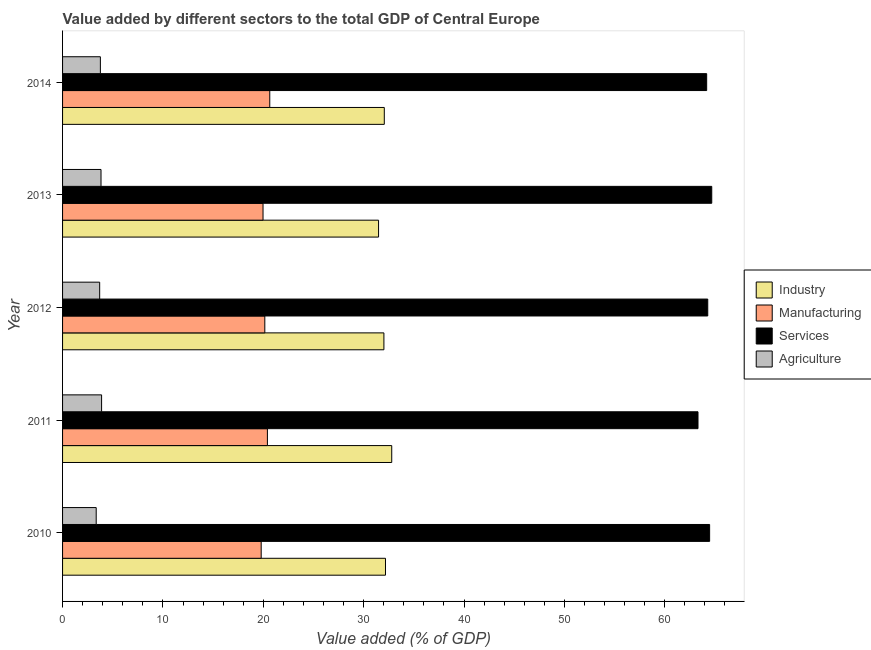How many groups of bars are there?
Your answer should be very brief. 5. What is the value added by manufacturing sector in 2011?
Offer a terse response. 20.41. Across all years, what is the maximum value added by agricultural sector?
Provide a short and direct response. 3.89. Across all years, what is the minimum value added by manufacturing sector?
Your answer should be very brief. 19.79. In which year was the value added by agricultural sector minimum?
Give a very brief answer. 2010. What is the total value added by manufacturing sector in the graph?
Provide a succinct answer. 100.97. What is the difference between the value added by industrial sector in 2012 and that in 2013?
Your answer should be compact. 0.53. What is the difference between the value added by manufacturing sector in 2014 and the value added by services sector in 2012?
Make the answer very short. -43.64. What is the average value added by services sector per year?
Your answer should be compact. 64.19. In the year 2014, what is the difference between the value added by services sector and value added by agricultural sector?
Ensure brevity in your answer.  60.41. In how many years, is the value added by services sector greater than 46 %?
Keep it short and to the point. 5. What is the ratio of the value added by manufacturing sector in 2010 to that in 2011?
Offer a terse response. 0.97. Is the value added by industrial sector in 2010 less than that in 2011?
Make the answer very short. Yes. What is the difference between the highest and the second highest value added by industrial sector?
Provide a short and direct response. 0.62. What is the difference between the highest and the lowest value added by industrial sector?
Keep it short and to the point. 1.31. What does the 2nd bar from the top in 2013 represents?
Your response must be concise. Services. What does the 4th bar from the bottom in 2012 represents?
Provide a succinct answer. Agriculture. How many bars are there?
Provide a succinct answer. 20. Are all the bars in the graph horizontal?
Your answer should be compact. Yes. How many years are there in the graph?
Provide a short and direct response. 5. What is the difference between two consecutive major ticks on the X-axis?
Ensure brevity in your answer.  10. Does the graph contain any zero values?
Ensure brevity in your answer.  No. Does the graph contain grids?
Your answer should be compact. No. What is the title of the graph?
Give a very brief answer. Value added by different sectors to the total GDP of Central Europe. Does "Corruption" appear as one of the legend labels in the graph?
Your response must be concise. No. What is the label or title of the X-axis?
Keep it short and to the point. Value added (% of GDP). What is the label or title of the Y-axis?
Your answer should be compact. Year. What is the Value added (% of GDP) in Industry in 2010?
Make the answer very short. 32.18. What is the Value added (% of GDP) of Manufacturing in 2010?
Provide a succinct answer. 19.79. What is the Value added (% of GDP) of Services in 2010?
Your answer should be compact. 64.47. What is the Value added (% of GDP) in Agriculture in 2010?
Offer a terse response. 3.35. What is the Value added (% of GDP) in Industry in 2011?
Offer a terse response. 32.8. What is the Value added (% of GDP) of Manufacturing in 2011?
Your answer should be very brief. 20.41. What is the Value added (% of GDP) of Services in 2011?
Your answer should be very brief. 63.31. What is the Value added (% of GDP) in Agriculture in 2011?
Your answer should be very brief. 3.89. What is the Value added (% of GDP) in Industry in 2012?
Your answer should be compact. 32.02. What is the Value added (% of GDP) in Manufacturing in 2012?
Ensure brevity in your answer.  20.15. What is the Value added (% of GDP) in Services in 2012?
Provide a succinct answer. 64.28. What is the Value added (% of GDP) in Agriculture in 2012?
Offer a terse response. 3.7. What is the Value added (% of GDP) of Industry in 2013?
Make the answer very short. 31.49. What is the Value added (% of GDP) of Manufacturing in 2013?
Keep it short and to the point. 19.97. What is the Value added (% of GDP) in Services in 2013?
Ensure brevity in your answer.  64.68. What is the Value added (% of GDP) of Agriculture in 2013?
Provide a short and direct response. 3.83. What is the Value added (% of GDP) in Industry in 2014?
Provide a succinct answer. 32.06. What is the Value added (% of GDP) of Manufacturing in 2014?
Provide a succinct answer. 20.65. What is the Value added (% of GDP) in Services in 2014?
Offer a very short reply. 64.18. What is the Value added (% of GDP) of Agriculture in 2014?
Offer a very short reply. 3.77. Across all years, what is the maximum Value added (% of GDP) of Industry?
Ensure brevity in your answer.  32.8. Across all years, what is the maximum Value added (% of GDP) of Manufacturing?
Offer a very short reply. 20.65. Across all years, what is the maximum Value added (% of GDP) in Services?
Make the answer very short. 64.68. Across all years, what is the maximum Value added (% of GDP) of Agriculture?
Your answer should be very brief. 3.89. Across all years, what is the minimum Value added (% of GDP) in Industry?
Keep it short and to the point. 31.49. Across all years, what is the minimum Value added (% of GDP) of Manufacturing?
Make the answer very short. 19.79. Across all years, what is the minimum Value added (% of GDP) in Services?
Keep it short and to the point. 63.31. Across all years, what is the minimum Value added (% of GDP) of Agriculture?
Offer a very short reply. 3.35. What is the total Value added (% of GDP) of Industry in the graph?
Give a very brief answer. 160.53. What is the total Value added (% of GDP) in Manufacturing in the graph?
Provide a short and direct response. 100.97. What is the total Value added (% of GDP) of Services in the graph?
Offer a very short reply. 320.93. What is the total Value added (% of GDP) in Agriculture in the graph?
Your answer should be very brief. 18.54. What is the difference between the Value added (% of GDP) of Industry in 2010 and that in 2011?
Provide a short and direct response. -0.62. What is the difference between the Value added (% of GDP) of Manufacturing in 2010 and that in 2011?
Offer a very short reply. -0.62. What is the difference between the Value added (% of GDP) in Services in 2010 and that in 2011?
Provide a short and direct response. 1.16. What is the difference between the Value added (% of GDP) in Agriculture in 2010 and that in 2011?
Keep it short and to the point. -0.54. What is the difference between the Value added (% of GDP) of Industry in 2010 and that in 2012?
Keep it short and to the point. 0.16. What is the difference between the Value added (% of GDP) in Manufacturing in 2010 and that in 2012?
Offer a very short reply. -0.36. What is the difference between the Value added (% of GDP) of Services in 2010 and that in 2012?
Ensure brevity in your answer.  0.19. What is the difference between the Value added (% of GDP) of Agriculture in 2010 and that in 2012?
Make the answer very short. -0.35. What is the difference between the Value added (% of GDP) of Industry in 2010 and that in 2013?
Your answer should be compact. 0.69. What is the difference between the Value added (% of GDP) in Manufacturing in 2010 and that in 2013?
Give a very brief answer. -0.18. What is the difference between the Value added (% of GDP) in Services in 2010 and that in 2013?
Provide a succinct answer. -0.21. What is the difference between the Value added (% of GDP) of Agriculture in 2010 and that in 2013?
Offer a very short reply. -0.48. What is the difference between the Value added (% of GDP) of Industry in 2010 and that in 2014?
Offer a terse response. 0.12. What is the difference between the Value added (% of GDP) of Manufacturing in 2010 and that in 2014?
Your answer should be compact. -0.86. What is the difference between the Value added (% of GDP) in Services in 2010 and that in 2014?
Give a very brief answer. 0.3. What is the difference between the Value added (% of GDP) of Agriculture in 2010 and that in 2014?
Give a very brief answer. -0.41. What is the difference between the Value added (% of GDP) of Industry in 2011 and that in 2012?
Keep it short and to the point. 0.78. What is the difference between the Value added (% of GDP) of Manufacturing in 2011 and that in 2012?
Provide a succinct answer. 0.26. What is the difference between the Value added (% of GDP) in Services in 2011 and that in 2012?
Provide a short and direct response. -0.97. What is the difference between the Value added (% of GDP) of Agriculture in 2011 and that in 2012?
Give a very brief answer. 0.19. What is the difference between the Value added (% of GDP) in Industry in 2011 and that in 2013?
Make the answer very short. 1.31. What is the difference between the Value added (% of GDP) in Manufacturing in 2011 and that in 2013?
Make the answer very short. 0.44. What is the difference between the Value added (% of GDP) in Services in 2011 and that in 2013?
Your answer should be compact. -1.37. What is the difference between the Value added (% of GDP) of Agriculture in 2011 and that in 2013?
Your answer should be compact. 0.06. What is the difference between the Value added (% of GDP) of Industry in 2011 and that in 2014?
Your answer should be very brief. 0.74. What is the difference between the Value added (% of GDP) of Manufacturing in 2011 and that in 2014?
Ensure brevity in your answer.  -0.24. What is the difference between the Value added (% of GDP) of Services in 2011 and that in 2014?
Offer a very short reply. -0.86. What is the difference between the Value added (% of GDP) in Agriculture in 2011 and that in 2014?
Give a very brief answer. 0.12. What is the difference between the Value added (% of GDP) in Industry in 2012 and that in 2013?
Make the answer very short. 0.53. What is the difference between the Value added (% of GDP) in Manufacturing in 2012 and that in 2013?
Your answer should be compact. 0.18. What is the difference between the Value added (% of GDP) of Services in 2012 and that in 2013?
Your answer should be very brief. -0.4. What is the difference between the Value added (% of GDP) in Agriculture in 2012 and that in 2013?
Provide a short and direct response. -0.13. What is the difference between the Value added (% of GDP) of Industry in 2012 and that in 2014?
Ensure brevity in your answer.  -0.04. What is the difference between the Value added (% of GDP) of Manufacturing in 2012 and that in 2014?
Offer a very short reply. -0.49. What is the difference between the Value added (% of GDP) in Services in 2012 and that in 2014?
Ensure brevity in your answer.  0.11. What is the difference between the Value added (% of GDP) in Agriculture in 2012 and that in 2014?
Your response must be concise. -0.07. What is the difference between the Value added (% of GDP) of Industry in 2013 and that in 2014?
Ensure brevity in your answer.  -0.57. What is the difference between the Value added (% of GDP) of Manufacturing in 2013 and that in 2014?
Keep it short and to the point. -0.67. What is the difference between the Value added (% of GDP) of Services in 2013 and that in 2014?
Provide a short and direct response. 0.51. What is the difference between the Value added (% of GDP) of Agriculture in 2013 and that in 2014?
Your response must be concise. 0.06. What is the difference between the Value added (% of GDP) of Industry in 2010 and the Value added (% of GDP) of Manufacturing in 2011?
Keep it short and to the point. 11.77. What is the difference between the Value added (% of GDP) of Industry in 2010 and the Value added (% of GDP) of Services in 2011?
Keep it short and to the point. -31.14. What is the difference between the Value added (% of GDP) in Industry in 2010 and the Value added (% of GDP) in Agriculture in 2011?
Give a very brief answer. 28.29. What is the difference between the Value added (% of GDP) in Manufacturing in 2010 and the Value added (% of GDP) in Services in 2011?
Offer a very short reply. -43.52. What is the difference between the Value added (% of GDP) of Manufacturing in 2010 and the Value added (% of GDP) of Agriculture in 2011?
Keep it short and to the point. 15.9. What is the difference between the Value added (% of GDP) of Services in 2010 and the Value added (% of GDP) of Agriculture in 2011?
Make the answer very short. 60.58. What is the difference between the Value added (% of GDP) of Industry in 2010 and the Value added (% of GDP) of Manufacturing in 2012?
Make the answer very short. 12.02. What is the difference between the Value added (% of GDP) in Industry in 2010 and the Value added (% of GDP) in Services in 2012?
Your answer should be compact. -32.11. What is the difference between the Value added (% of GDP) in Industry in 2010 and the Value added (% of GDP) in Agriculture in 2012?
Make the answer very short. 28.48. What is the difference between the Value added (% of GDP) of Manufacturing in 2010 and the Value added (% of GDP) of Services in 2012?
Your answer should be very brief. -44.49. What is the difference between the Value added (% of GDP) of Manufacturing in 2010 and the Value added (% of GDP) of Agriculture in 2012?
Offer a terse response. 16.09. What is the difference between the Value added (% of GDP) in Services in 2010 and the Value added (% of GDP) in Agriculture in 2012?
Ensure brevity in your answer.  60.77. What is the difference between the Value added (% of GDP) in Industry in 2010 and the Value added (% of GDP) in Manufacturing in 2013?
Provide a short and direct response. 12.2. What is the difference between the Value added (% of GDP) of Industry in 2010 and the Value added (% of GDP) of Services in 2013?
Ensure brevity in your answer.  -32.51. What is the difference between the Value added (% of GDP) in Industry in 2010 and the Value added (% of GDP) in Agriculture in 2013?
Make the answer very short. 28.34. What is the difference between the Value added (% of GDP) of Manufacturing in 2010 and the Value added (% of GDP) of Services in 2013?
Keep it short and to the point. -44.89. What is the difference between the Value added (% of GDP) in Manufacturing in 2010 and the Value added (% of GDP) in Agriculture in 2013?
Provide a succinct answer. 15.96. What is the difference between the Value added (% of GDP) of Services in 2010 and the Value added (% of GDP) of Agriculture in 2013?
Provide a short and direct response. 60.64. What is the difference between the Value added (% of GDP) in Industry in 2010 and the Value added (% of GDP) in Manufacturing in 2014?
Keep it short and to the point. 11.53. What is the difference between the Value added (% of GDP) in Industry in 2010 and the Value added (% of GDP) in Services in 2014?
Offer a very short reply. -32. What is the difference between the Value added (% of GDP) of Industry in 2010 and the Value added (% of GDP) of Agriculture in 2014?
Provide a short and direct response. 28.41. What is the difference between the Value added (% of GDP) in Manufacturing in 2010 and the Value added (% of GDP) in Services in 2014?
Your answer should be compact. -44.39. What is the difference between the Value added (% of GDP) of Manufacturing in 2010 and the Value added (% of GDP) of Agriculture in 2014?
Make the answer very short. 16.02. What is the difference between the Value added (% of GDP) in Services in 2010 and the Value added (% of GDP) in Agriculture in 2014?
Your response must be concise. 60.71. What is the difference between the Value added (% of GDP) in Industry in 2011 and the Value added (% of GDP) in Manufacturing in 2012?
Your answer should be very brief. 12.65. What is the difference between the Value added (% of GDP) in Industry in 2011 and the Value added (% of GDP) in Services in 2012?
Offer a terse response. -31.49. What is the difference between the Value added (% of GDP) of Industry in 2011 and the Value added (% of GDP) of Agriculture in 2012?
Your answer should be compact. 29.1. What is the difference between the Value added (% of GDP) of Manufacturing in 2011 and the Value added (% of GDP) of Services in 2012?
Your response must be concise. -43.88. What is the difference between the Value added (% of GDP) in Manufacturing in 2011 and the Value added (% of GDP) in Agriculture in 2012?
Your response must be concise. 16.71. What is the difference between the Value added (% of GDP) of Services in 2011 and the Value added (% of GDP) of Agriculture in 2012?
Ensure brevity in your answer.  59.62. What is the difference between the Value added (% of GDP) of Industry in 2011 and the Value added (% of GDP) of Manufacturing in 2013?
Provide a succinct answer. 12.82. What is the difference between the Value added (% of GDP) in Industry in 2011 and the Value added (% of GDP) in Services in 2013?
Your response must be concise. -31.89. What is the difference between the Value added (% of GDP) of Industry in 2011 and the Value added (% of GDP) of Agriculture in 2013?
Your response must be concise. 28.97. What is the difference between the Value added (% of GDP) of Manufacturing in 2011 and the Value added (% of GDP) of Services in 2013?
Make the answer very short. -44.27. What is the difference between the Value added (% of GDP) of Manufacturing in 2011 and the Value added (% of GDP) of Agriculture in 2013?
Make the answer very short. 16.58. What is the difference between the Value added (% of GDP) in Services in 2011 and the Value added (% of GDP) in Agriculture in 2013?
Provide a short and direct response. 59.48. What is the difference between the Value added (% of GDP) of Industry in 2011 and the Value added (% of GDP) of Manufacturing in 2014?
Your response must be concise. 12.15. What is the difference between the Value added (% of GDP) in Industry in 2011 and the Value added (% of GDP) in Services in 2014?
Keep it short and to the point. -31.38. What is the difference between the Value added (% of GDP) of Industry in 2011 and the Value added (% of GDP) of Agriculture in 2014?
Your answer should be very brief. 29.03. What is the difference between the Value added (% of GDP) of Manufacturing in 2011 and the Value added (% of GDP) of Services in 2014?
Provide a succinct answer. -43.77. What is the difference between the Value added (% of GDP) of Manufacturing in 2011 and the Value added (% of GDP) of Agriculture in 2014?
Give a very brief answer. 16.64. What is the difference between the Value added (% of GDP) of Services in 2011 and the Value added (% of GDP) of Agriculture in 2014?
Provide a succinct answer. 59.55. What is the difference between the Value added (% of GDP) in Industry in 2012 and the Value added (% of GDP) in Manufacturing in 2013?
Provide a short and direct response. 12.04. What is the difference between the Value added (% of GDP) in Industry in 2012 and the Value added (% of GDP) in Services in 2013?
Provide a short and direct response. -32.67. What is the difference between the Value added (% of GDP) of Industry in 2012 and the Value added (% of GDP) of Agriculture in 2013?
Your response must be concise. 28.19. What is the difference between the Value added (% of GDP) of Manufacturing in 2012 and the Value added (% of GDP) of Services in 2013?
Your response must be concise. -44.53. What is the difference between the Value added (% of GDP) in Manufacturing in 2012 and the Value added (% of GDP) in Agriculture in 2013?
Your answer should be very brief. 16.32. What is the difference between the Value added (% of GDP) of Services in 2012 and the Value added (% of GDP) of Agriculture in 2013?
Keep it short and to the point. 60.45. What is the difference between the Value added (% of GDP) in Industry in 2012 and the Value added (% of GDP) in Manufacturing in 2014?
Keep it short and to the point. 11.37. What is the difference between the Value added (% of GDP) in Industry in 2012 and the Value added (% of GDP) in Services in 2014?
Your answer should be very brief. -32.16. What is the difference between the Value added (% of GDP) in Industry in 2012 and the Value added (% of GDP) in Agriculture in 2014?
Provide a succinct answer. 28.25. What is the difference between the Value added (% of GDP) in Manufacturing in 2012 and the Value added (% of GDP) in Services in 2014?
Your response must be concise. -44.03. What is the difference between the Value added (% of GDP) of Manufacturing in 2012 and the Value added (% of GDP) of Agriculture in 2014?
Your response must be concise. 16.38. What is the difference between the Value added (% of GDP) in Services in 2012 and the Value added (% of GDP) in Agriculture in 2014?
Offer a terse response. 60.52. What is the difference between the Value added (% of GDP) of Industry in 2013 and the Value added (% of GDP) of Manufacturing in 2014?
Offer a terse response. 10.84. What is the difference between the Value added (% of GDP) of Industry in 2013 and the Value added (% of GDP) of Services in 2014?
Provide a succinct answer. -32.69. What is the difference between the Value added (% of GDP) of Industry in 2013 and the Value added (% of GDP) of Agriculture in 2014?
Ensure brevity in your answer.  27.72. What is the difference between the Value added (% of GDP) of Manufacturing in 2013 and the Value added (% of GDP) of Services in 2014?
Offer a terse response. -44.2. What is the difference between the Value added (% of GDP) of Manufacturing in 2013 and the Value added (% of GDP) of Agriculture in 2014?
Provide a succinct answer. 16.21. What is the difference between the Value added (% of GDP) of Services in 2013 and the Value added (% of GDP) of Agriculture in 2014?
Ensure brevity in your answer.  60.92. What is the average Value added (% of GDP) in Industry per year?
Your response must be concise. 32.11. What is the average Value added (% of GDP) in Manufacturing per year?
Offer a very short reply. 20.19. What is the average Value added (% of GDP) in Services per year?
Provide a succinct answer. 64.19. What is the average Value added (% of GDP) of Agriculture per year?
Make the answer very short. 3.71. In the year 2010, what is the difference between the Value added (% of GDP) of Industry and Value added (% of GDP) of Manufacturing?
Your answer should be compact. 12.39. In the year 2010, what is the difference between the Value added (% of GDP) in Industry and Value added (% of GDP) in Services?
Give a very brief answer. -32.3. In the year 2010, what is the difference between the Value added (% of GDP) of Industry and Value added (% of GDP) of Agriculture?
Offer a terse response. 28.82. In the year 2010, what is the difference between the Value added (% of GDP) in Manufacturing and Value added (% of GDP) in Services?
Keep it short and to the point. -44.68. In the year 2010, what is the difference between the Value added (% of GDP) in Manufacturing and Value added (% of GDP) in Agriculture?
Your answer should be very brief. 16.44. In the year 2010, what is the difference between the Value added (% of GDP) in Services and Value added (% of GDP) in Agriculture?
Give a very brief answer. 61.12. In the year 2011, what is the difference between the Value added (% of GDP) in Industry and Value added (% of GDP) in Manufacturing?
Give a very brief answer. 12.39. In the year 2011, what is the difference between the Value added (% of GDP) of Industry and Value added (% of GDP) of Services?
Make the answer very short. -30.52. In the year 2011, what is the difference between the Value added (% of GDP) in Industry and Value added (% of GDP) in Agriculture?
Make the answer very short. 28.91. In the year 2011, what is the difference between the Value added (% of GDP) in Manufacturing and Value added (% of GDP) in Services?
Ensure brevity in your answer.  -42.9. In the year 2011, what is the difference between the Value added (% of GDP) of Manufacturing and Value added (% of GDP) of Agriculture?
Your answer should be very brief. 16.52. In the year 2011, what is the difference between the Value added (% of GDP) of Services and Value added (% of GDP) of Agriculture?
Keep it short and to the point. 59.43. In the year 2012, what is the difference between the Value added (% of GDP) of Industry and Value added (% of GDP) of Manufacturing?
Offer a terse response. 11.87. In the year 2012, what is the difference between the Value added (% of GDP) in Industry and Value added (% of GDP) in Services?
Offer a terse response. -32.27. In the year 2012, what is the difference between the Value added (% of GDP) in Industry and Value added (% of GDP) in Agriculture?
Keep it short and to the point. 28.32. In the year 2012, what is the difference between the Value added (% of GDP) of Manufacturing and Value added (% of GDP) of Services?
Your answer should be very brief. -44.13. In the year 2012, what is the difference between the Value added (% of GDP) in Manufacturing and Value added (% of GDP) in Agriculture?
Give a very brief answer. 16.45. In the year 2012, what is the difference between the Value added (% of GDP) of Services and Value added (% of GDP) of Agriculture?
Offer a terse response. 60.59. In the year 2013, what is the difference between the Value added (% of GDP) in Industry and Value added (% of GDP) in Manufacturing?
Your response must be concise. 11.51. In the year 2013, what is the difference between the Value added (% of GDP) in Industry and Value added (% of GDP) in Services?
Your response must be concise. -33.2. In the year 2013, what is the difference between the Value added (% of GDP) of Industry and Value added (% of GDP) of Agriculture?
Your response must be concise. 27.65. In the year 2013, what is the difference between the Value added (% of GDP) of Manufacturing and Value added (% of GDP) of Services?
Keep it short and to the point. -44.71. In the year 2013, what is the difference between the Value added (% of GDP) of Manufacturing and Value added (% of GDP) of Agriculture?
Offer a terse response. 16.14. In the year 2013, what is the difference between the Value added (% of GDP) in Services and Value added (% of GDP) in Agriculture?
Make the answer very short. 60.85. In the year 2014, what is the difference between the Value added (% of GDP) of Industry and Value added (% of GDP) of Manufacturing?
Your answer should be very brief. 11.41. In the year 2014, what is the difference between the Value added (% of GDP) of Industry and Value added (% of GDP) of Services?
Provide a short and direct response. -32.12. In the year 2014, what is the difference between the Value added (% of GDP) of Industry and Value added (% of GDP) of Agriculture?
Give a very brief answer. 28.29. In the year 2014, what is the difference between the Value added (% of GDP) in Manufacturing and Value added (% of GDP) in Services?
Your answer should be very brief. -43.53. In the year 2014, what is the difference between the Value added (% of GDP) in Manufacturing and Value added (% of GDP) in Agriculture?
Give a very brief answer. 16.88. In the year 2014, what is the difference between the Value added (% of GDP) in Services and Value added (% of GDP) in Agriculture?
Your answer should be very brief. 60.41. What is the ratio of the Value added (% of GDP) in Manufacturing in 2010 to that in 2011?
Give a very brief answer. 0.97. What is the ratio of the Value added (% of GDP) in Services in 2010 to that in 2011?
Provide a succinct answer. 1.02. What is the ratio of the Value added (% of GDP) of Agriculture in 2010 to that in 2011?
Your answer should be compact. 0.86. What is the ratio of the Value added (% of GDP) of Industry in 2010 to that in 2012?
Your response must be concise. 1. What is the ratio of the Value added (% of GDP) of Manufacturing in 2010 to that in 2012?
Make the answer very short. 0.98. What is the ratio of the Value added (% of GDP) of Services in 2010 to that in 2012?
Give a very brief answer. 1. What is the ratio of the Value added (% of GDP) of Agriculture in 2010 to that in 2012?
Provide a short and direct response. 0.91. What is the ratio of the Value added (% of GDP) of Industry in 2010 to that in 2013?
Provide a succinct answer. 1.02. What is the ratio of the Value added (% of GDP) of Manufacturing in 2010 to that in 2013?
Your response must be concise. 0.99. What is the ratio of the Value added (% of GDP) in Manufacturing in 2010 to that in 2014?
Give a very brief answer. 0.96. What is the ratio of the Value added (% of GDP) in Services in 2010 to that in 2014?
Your response must be concise. 1. What is the ratio of the Value added (% of GDP) of Agriculture in 2010 to that in 2014?
Make the answer very short. 0.89. What is the ratio of the Value added (% of GDP) in Industry in 2011 to that in 2012?
Provide a short and direct response. 1.02. What is the ratio of the Value added (% of GDP) of Manufacturing in 2011 to that in 2012?
Provide a short and direct response. 1.01. What is the ratio of the Value added (% of GDP) of Services in 2011 to that in 2012?
Give a very brief answer. 0.98. What is the ratio of the Value added (% of GDP) in Agriculture in 2011 to that in 2012?
Offer a very short reply. 1.05. What is the ratio of the Value added (% of GDP) in Industry in 2011 to that in 2013?
Keep it short and to the point. 1.04. What is the ratio of the Value added (% of GDP) in Manufacturing in 2011 to that in 2013?
Your response must be concise. 1.02. What is the ratio of the Value added (% of GDP) in Services in 2011 to that in 2013?
Provide a short and direct response. 0.98. What is the ratio of the Value added (% of GDP) in Industry in 2011 to that in 2014?
Offer a very short reply. 1.02. What is the ratio of the Value added (% of GDP) of Manufacturing in 2011 to that in 2014?
Provide a succinct answer. 0.99. What is the ratio of the Value added (% of GDP) of Services in 2011 to that in 2014?
Give a very brief answer. 0.99. What is the ratio of the Value added (% of GDP) of Agriculture in 2011 to that in 2014?
Your answer should be very brief. 1.03. What is the ratio of the Value added (% of GDP) of Industry in 2012 to that in 2013?
Your answer should be very brief. 1.02. What is the ratio of the Value added (% of GDP) in Manufacturing in 2012 to that in 2013?
Provide a short and direct response. 1.01. What is the ratio of the Value added (% of GDP) in Services in 2012 to that in 2013?
Provide a succinct answer. 0.99. What is the ratio of the Value added (% of GDP) in Agriculture in 2012 to that in 2013?
Offer a very short reply. 0.97. What is the ratio of the Value added (% of GDP) in Manufacturing in 2012 to that in 2014?
Give a very brief answer. 0.98. What is the ratio of the Value added (% of GDP) in Services in 2012 to that in 2014?
Your response must be concise. 1. What is the ratio of the Value added (% of GDP) in Agriculture in 2012 to that in 2014?
Your answer should be compact. 0.98. What is the ratio of the Value added (% of GDP) of Industry in 2013 to that in 2014?
Make the answer very short. 0.98. What is the ratio of the Value added (% of GDP) of Manufacturing in 2013 to that in 2014?
Your answer should be compact. 0.97. What is the ratio of the Value added (% of GDP) in Services in 2013 to that in 2014?
Offer a terse response. 1.01. What is the ratio of the Value added (% of GDP) of Agriculture in 2013 to that in 2014?
Ensure brevity in your answer.  1.02. What is the difference between the highest and the second highest Value added (% of GDP) of Industry?
Keep it short and to the point. 0.62. What is the difference between the highest and the second highest Value added (% of GDP) of Manufacturing?
Your answer should be very brief. 0.24. What is the difference between the highest and the second highest Value added (% of GDP) of Services?
Provide a succinct answer. 0.21. What is the difference between the highest and the second highest Value added (% of GDP) of Agriculture?
Your response must be concise. 0.06. What is the difference between the highest and the lowest Value added (% of GDP) in Industry?
Offer a terse response. 1.31. What is the difference between the highest and the lowest Value added (% of GDP) of Manufacturing?
Ensure brevity in your answer.  0.86. What is the difference between the highest and the lowest Value added (% of GDP) of Services?
Provide a short and direct response. 1.37. What is the difference between the highest and the lowest Value added (% of GDP) in Agriculture?
Make the answer very short. 0.54. 